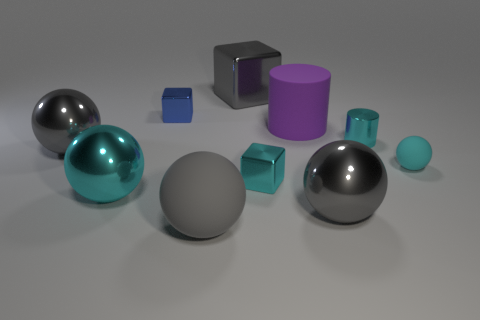Are there more blue matte balls than big cyan objects?
Make the answer very short. No. There is a matte ball that is the same color as the tiny cylinder; what is its size?
Provide a succinct answer. Small. There is a gray metal thing that is behind the big gray object that is on the left side of the big gray matte thing; what is its shape?
Ensure brevity in your answer.  Cube. There is a big cyan metallic thing that is in front of the purple thing that is behind the small cyan cube; is there a gray block that is in front of it?
Provide a short and direct response. No. What color is the sphere that is the same size as the cyan metallic cube?
Keep it short and to the point. Cyan. What is the shape of the metal object that is in front of the small cyan cylinder and behind the small rubber sphere?
Your answer should be compact. Sphere. There is a gray matte object that is in front of the small cube that is behind the large rubber cylinder; what size is it?
Your answer should be very brief. Large. What number of blocks are the same color as the metallic cylinder?
Provide a succinct answer. 1. How many other objects are the same size as the blue cube?
Give a very brief answer. 3. What is the size of the gray metal thing that is right of the gray matte ball and in front of the blue object?
Make the answer very short. Large. 